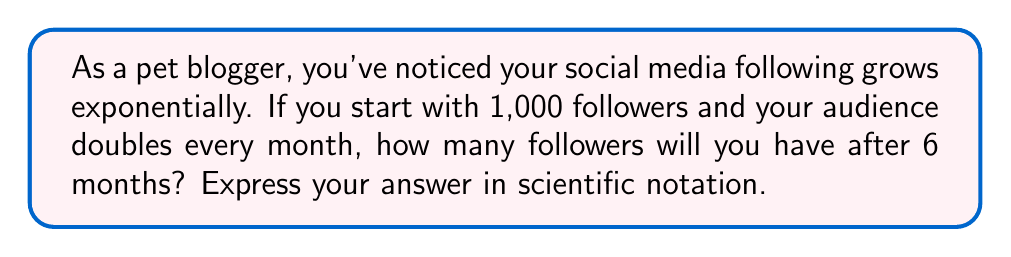Teach me how to tackle this problem. Let's approach this step-by-step:

1) We start with 1,000 followers.

2) The number of followers doubles every month, which means we multiply by 2 each month.

3) This can be expressed as an exponential function:
   $f(x) = 1000 \cdot 2^x$, where $x$ is the number of months.

4) We want to know the number of followers after 6 months, so we calculate $f(6)$:

   $f(6) = 1000 \cdot 2^6$

5) Let's calculate $2^6$:
   $2^6 = 2 \cdot 2 \cdot 2 \cdot 2 \cdot 2 \cdot 2 = 64$

6) Now we can complete our calculation:
   $f(6) = 1000 \cdot 64 = 64,000$

7) To express this in scientific notation, we move the decimal point 4 places to the left:
   $64,000 = 6.4 \times 10^4$

Therefore, after 6 months, you will have $6.4 \times 10^4$ followers.
Answer: $6.4 \times 10^4$ 